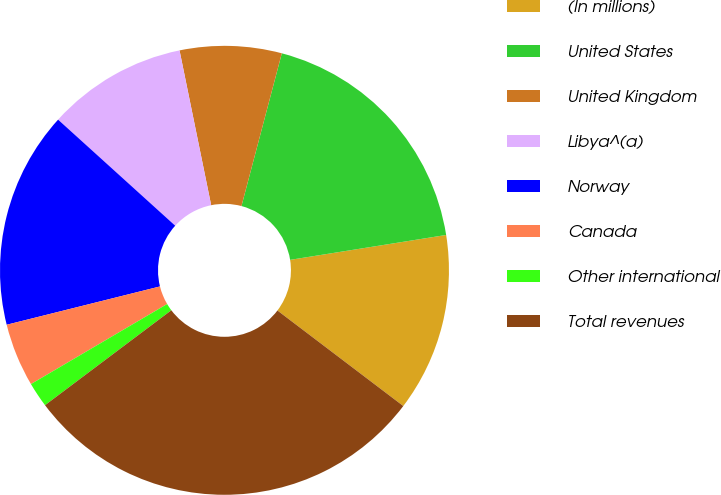Convert chart. <chart><loc_0><loc_0><loc_500><loc_500><pie_chart><fcel>(In millions)<fcel>United States<fcel>United Kingdom<fcel>Libya^(a)<fcel>Norway<fcel>Canada<fcel>Other international<fcel>Total revenues<nl><fcel>12.85%<fcel>18.37%<fcel>7.32%<fcel>10.08%<fcel>15.61%<fcel>4.56%<fcel>1.8%<fcel>29.41%<nl></chart> 